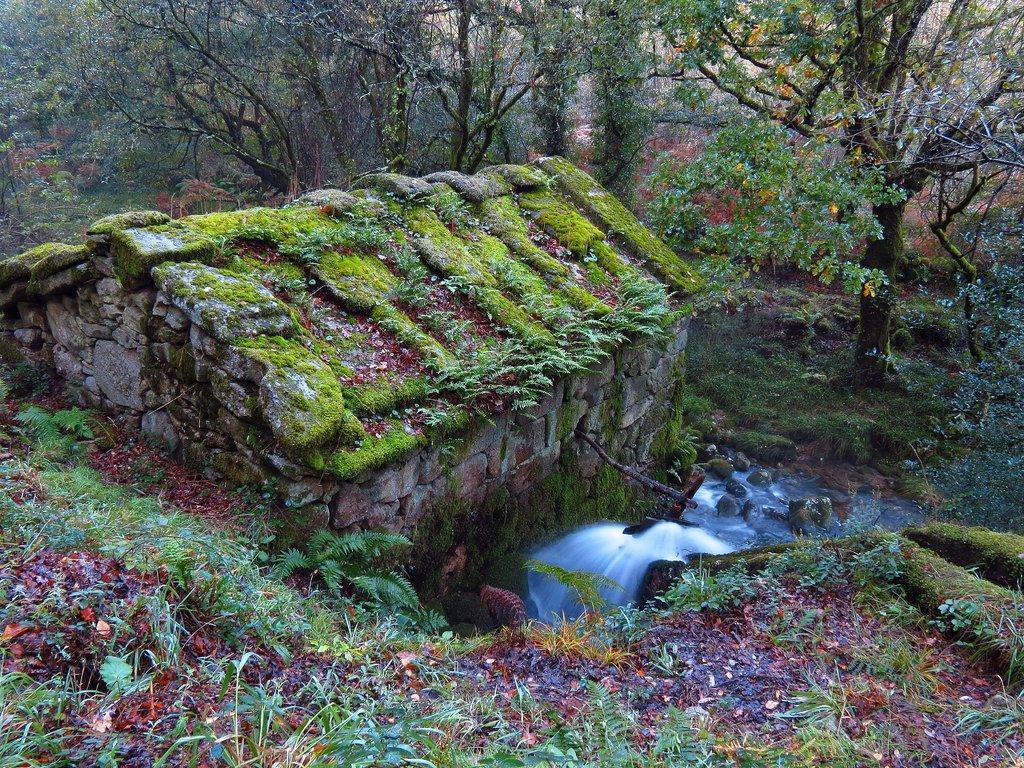Can you describe this image briefly? In this image I can see grass and trees in green color and I can also see water flowing. 